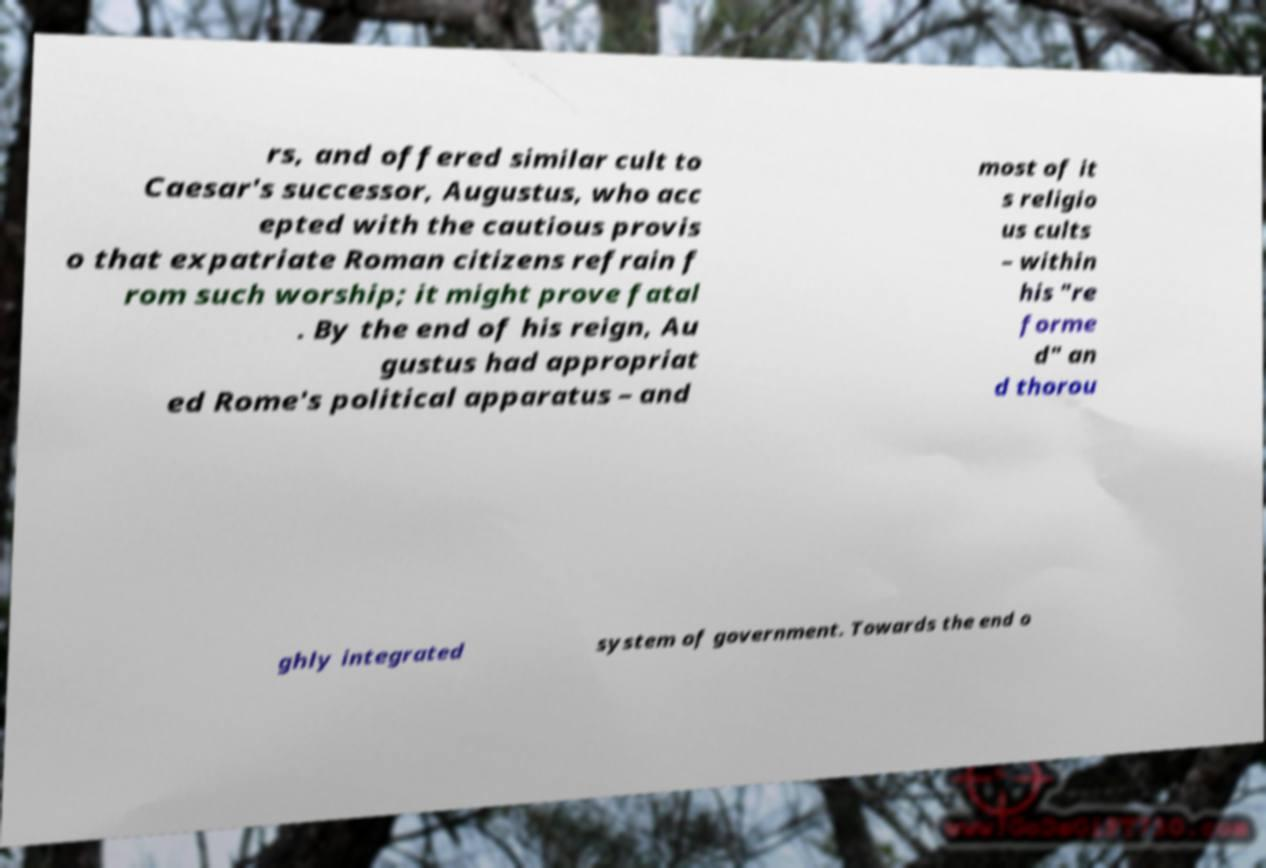Can you read and provide the text displayed in the image?This photo seems to have some interesting text. Can you extract and type it out for me? rs, and offered similar cult to Caesar's successor, Augustus, who acc epted with the cautious provis o that expatriate Roman citizens refrain f rom such worship; it might prove fatal . By the end of his reign, Au gustus had appropriat ed Rome's political apparatus – and most of it s religio us cults – within his "re forme d" an d thorou ghly integrated system of government. Towards the end o 